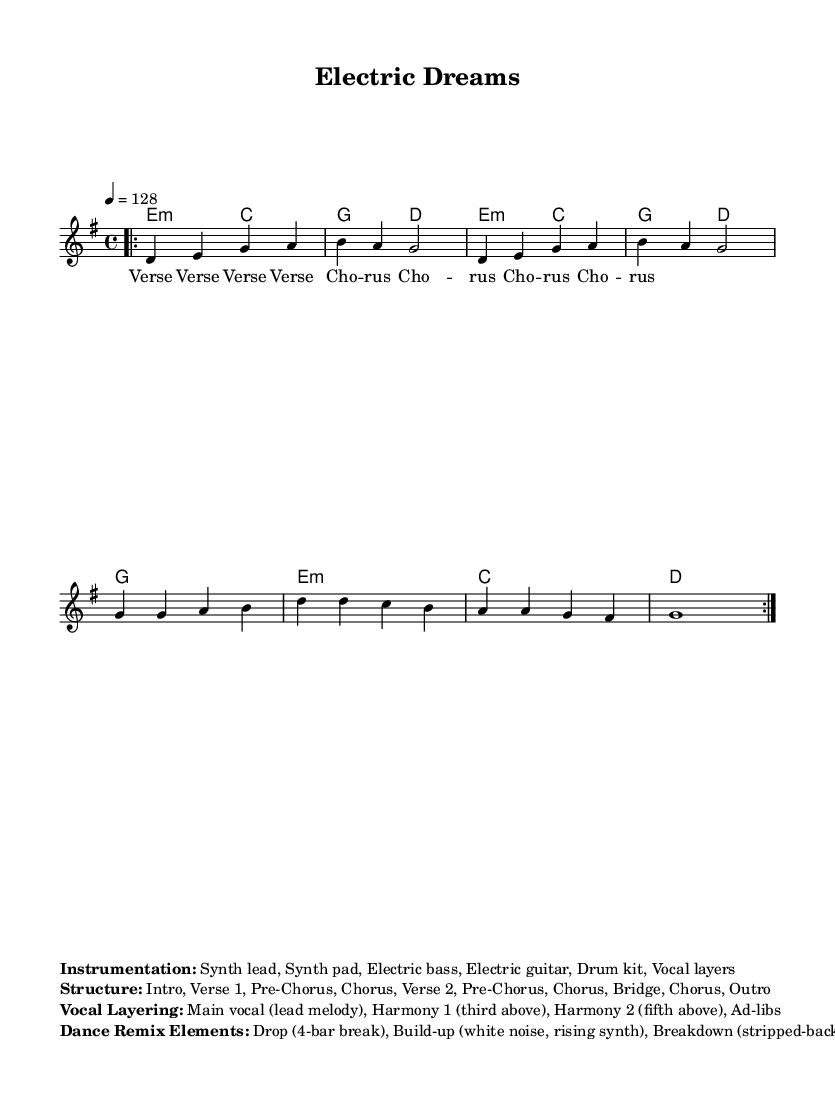What is the key signature of this music? The key signature shown at the beginning of the piece indicates that it is in G major, which has one sharp (F#).
Answer: G major What is the time signature of this music? The time signature appears in the beginning of the score, which is 4/4, indicating four beats per measure.
Answer: 4/4 What is the tempo marking of this piece? The tempo marking is indicated as quarter note equals 128, which sets the speed of the music.
Answer: 128 How many bars are in the verse? The verse is represented by the repeated music notations and consists of 8 bars as indicated by the structure.
Answer: 8 bars What are the primary instruments listed in the instrumentation? The instrumentation section lists six components including synth lead, synth pad, electric bass, electric guitar, drum kit, and vocal layers.
Answer: Synth lead, synth pad, electric bass, electric guitar, drum kit, vocal layers What type of vocal layering is used in this track? The vocal layering includes a main vocal for the lead melody, harmony parts that are a third and fifth above, and ad-libs for additional texture.
Answer: Main vocal, harmony 1, harmony 2, ad-libs What is a key element used in the dance remix section? The dance remix elements listed include a drop, build-up using white noise and rising synth, and a breakdown that strips back to the chorus.
Answer: Drop, build-up, breakdown 